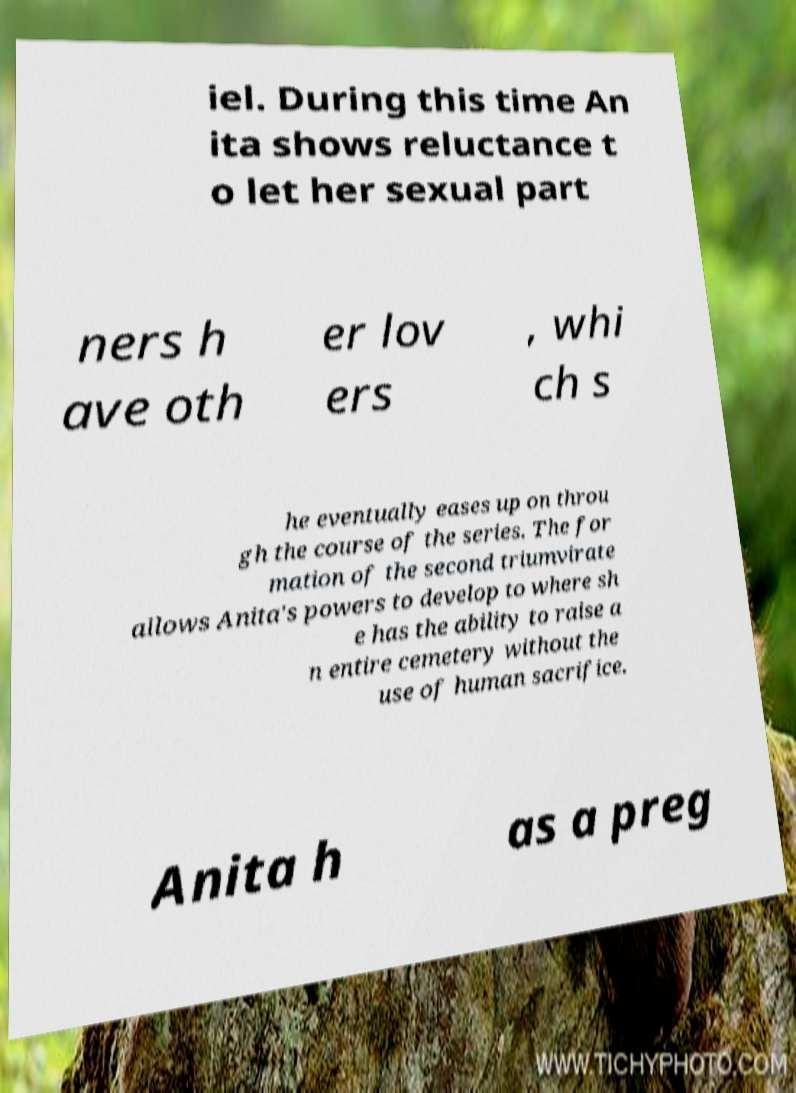For documentation purposes, I need the text within this image transcribed. Could you provide that? iel. During this time An ita shows reluctance t o let her sexual part ners h ave oth er lov ers , whi ch s he eventually eases up on throu gh the course of the series. The for mation of the second triumvirate allows Anita's powers to develop to where sh e has the ability to raise a n entire cemetery without the use of human sacrifice. Anita h as a preg 